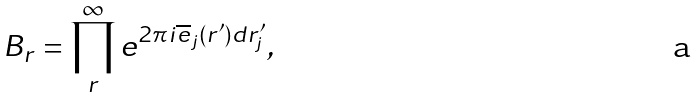Convert formula to latex. <formula><loc_0><loc_0><loc_500><loc_500>B _ { r } = \prod _ { r } ^ { \infty } e ^ { 2 \pi i \overline { e } _ { j } ( { r } ^ { \prime } ) d { r } ^ { \prime } _ { j } } ,</formula> 